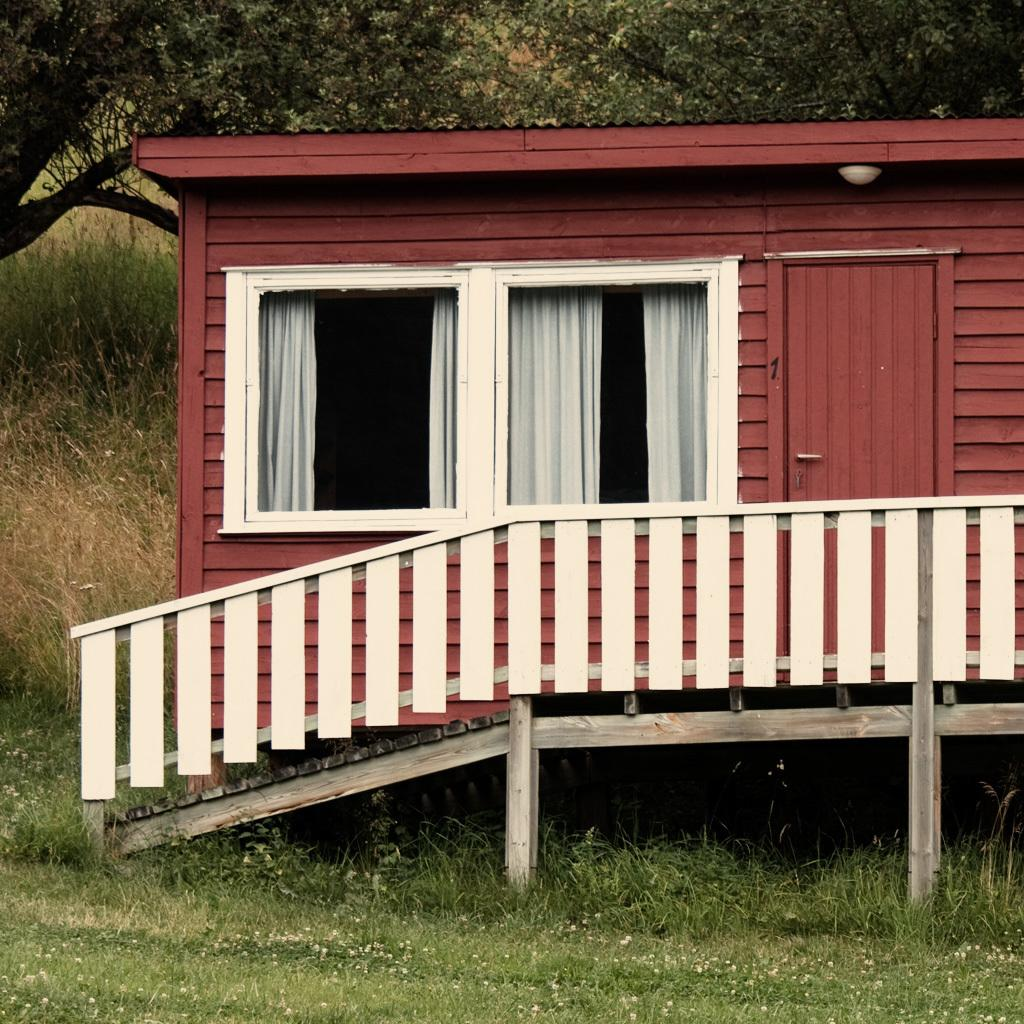What type of house is in the image? There is a wooden house in the image. What other natural elements can be seen in the image? There are plants, trees, and grass visible in the image. What type of vegetable is growing in the lunchroom in the image? There is no lunchroom or vegetable present in the image; it features a wooden house and natural elements like plants, trees, and grass. 